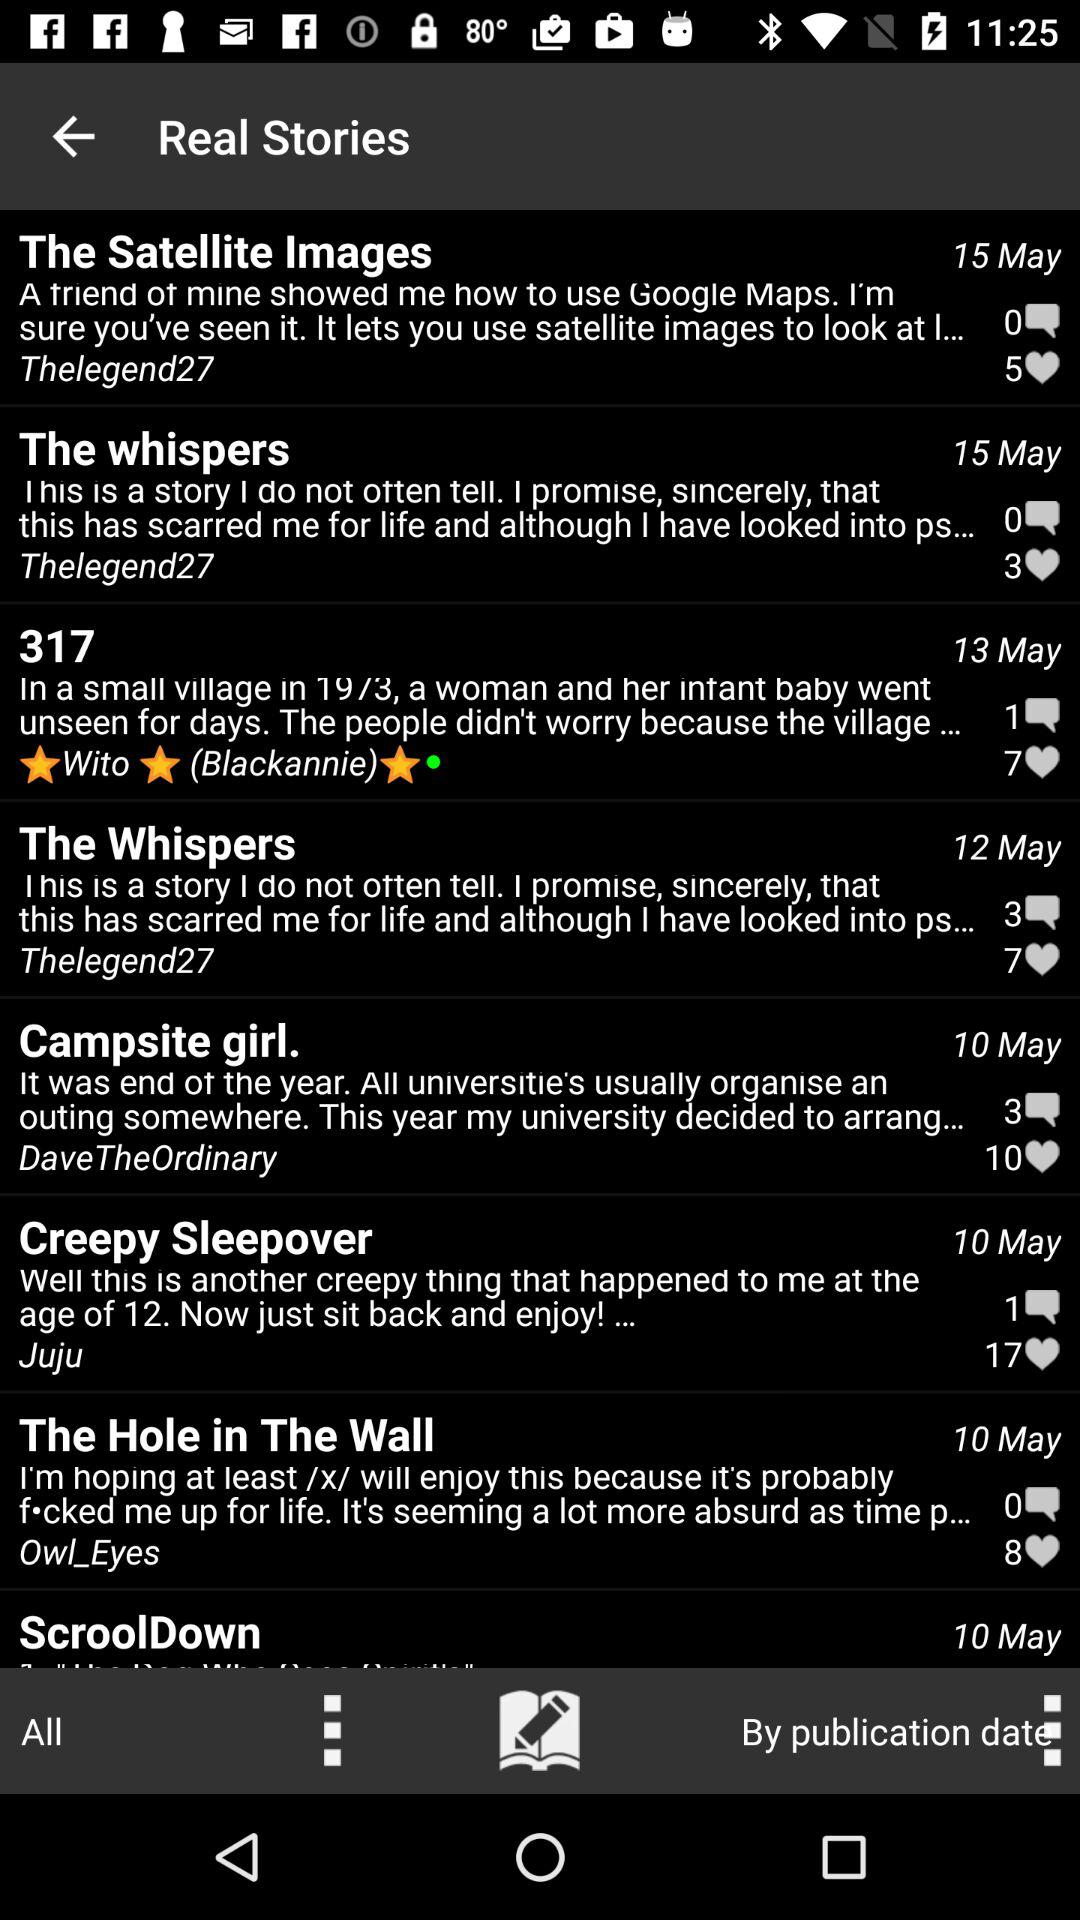How many hearts in The Satellite images?
When the provided information is insufficient, respond with <no answer>. <no answer> 